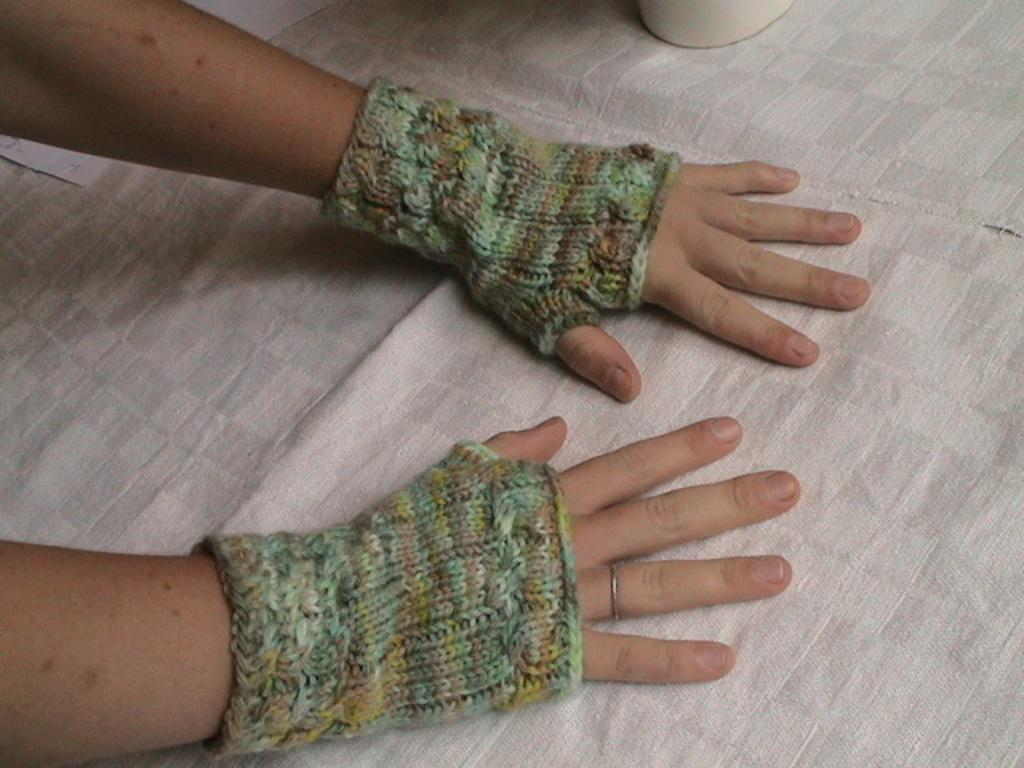What can be seen on the left side of the image? There is a person's hand in the image, and it is on the left side. What is covering the hand in the image? The hand is covered with gloves. What is the hand placed on in the image? The hand is placed on a white cloth. What type of poison is being used by the person in the image? There is no indication of poison or any dangerous substance in the image; it only shows a person's hand covered with gloves and placed on a white cloth. 